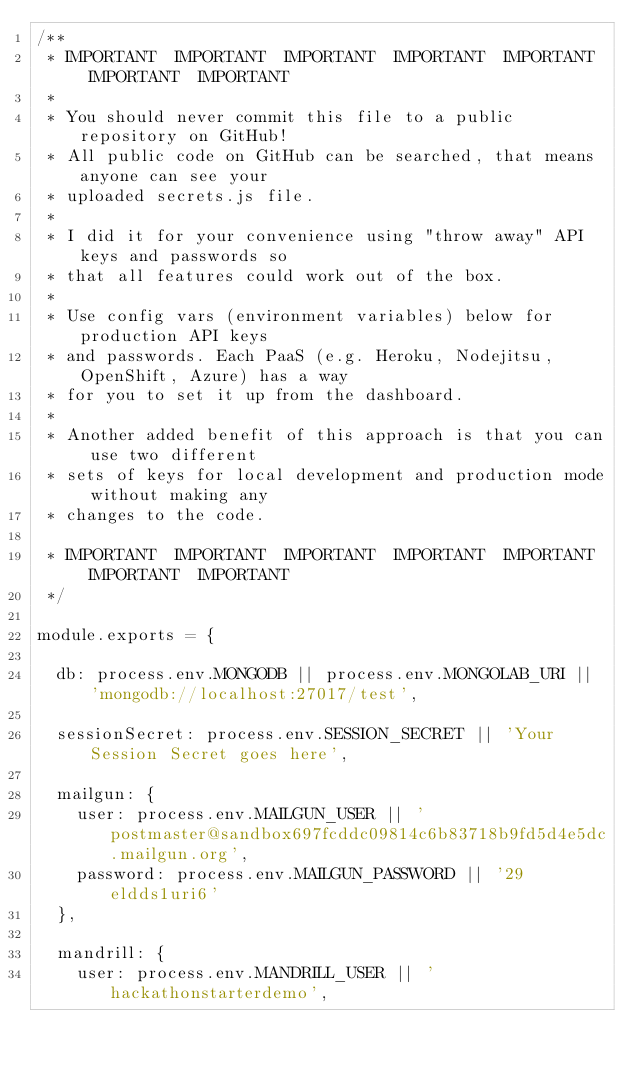<code> <loc_0><loc_0><loc_500><loc_500><_JavaScript_>/**
 * IMPORTANT  IMPORTANT  IMPORTANT  IMPORTANT  IMPORTANT  IMPORTANT  IMPORTANT
 *
 * You should never commit this file to a public repository on GitHub!
 * All public code on GitHub can be searched, that means anyone can see your
 * uploaded secrets.js file.
 *
 * I did it for your convenience using "throw away" API keys and passwords so
 * that all features could work out of the box.
 *
 * Use config vars (environment variables) below for production API keys
 * and passwords. Each PaaS (e.g. Heroku, Nodejitsu, OpenShift, Azure) has a way
 * for you to set it up from the dashboard.
 *
 * Another added benefit of this approach is that you can use two different
 * sets of keys for local development and production mode without making any
 * changes to the code.

 * IMPORTANT  IMPORTANT  IMPORTANT  IMPORTANT  IMPORTANT  IMPORTANT  IMPORTANT
 */

module.exports = {

  db: process.env.MONGODB || process.env.MONGOLAB_URI || 'mongodb://localhost:27017/test',

  sessionSecret: process.env.SESSION_SECRET || 'Your Session Secret goes here',

  mailgun: {
    user: process.env.MAILGUN_USER || 'postmaster@sandbox697fcddc09814c6b83718b9fd5d4e5dc.mailgun.org',
    password: process.env.MAILGUN_PASSWORD || '29eldds1uri6'
  },

  mandrill: {
    user: process.env.MANDRILL_USER || 'hackathonstarterdemo',</code> 